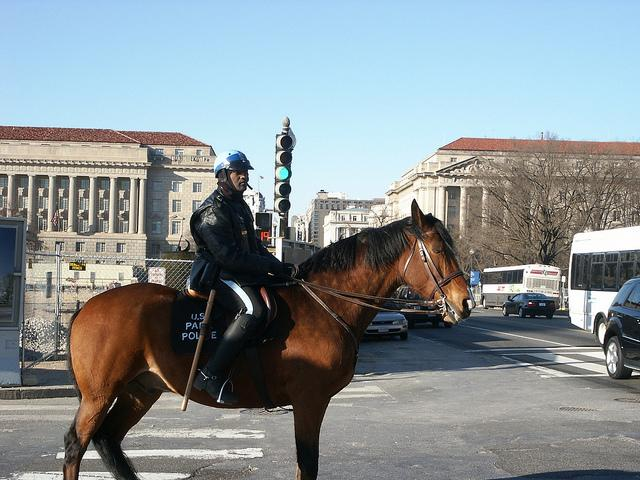Why is he on a horse?

Choices:
A) stole horse
B) showing off
C) can't walk
D) is patrolling is patrolling 